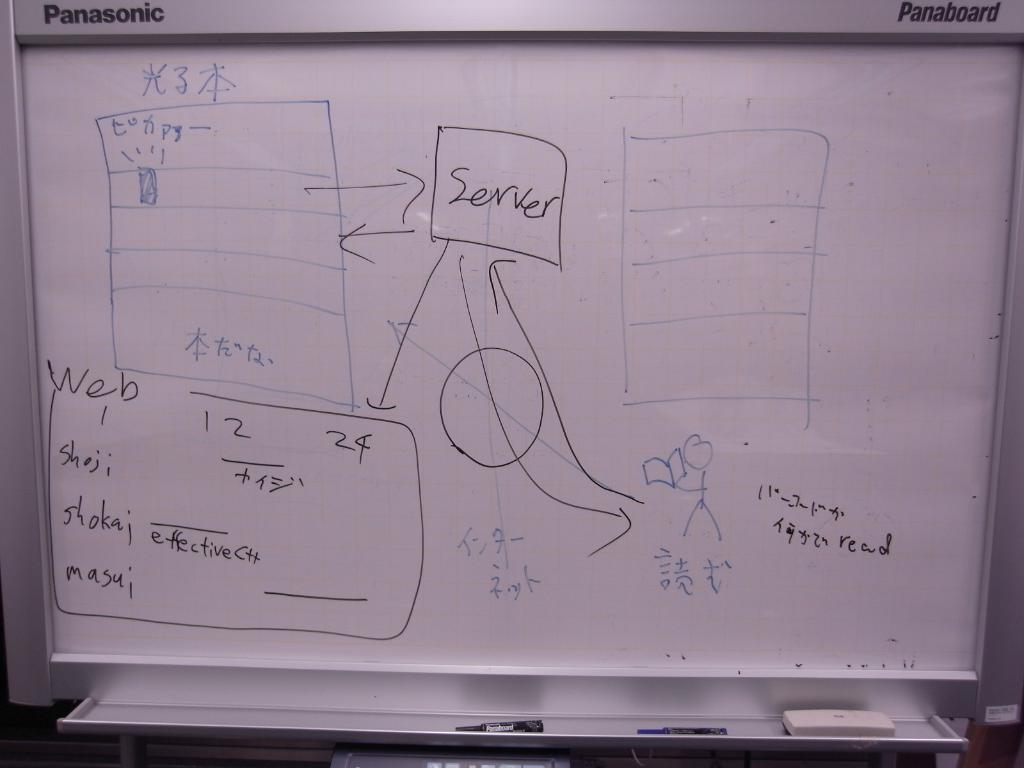What model of whiteboard is this?
Keep it short and to the point. Panasonic. 